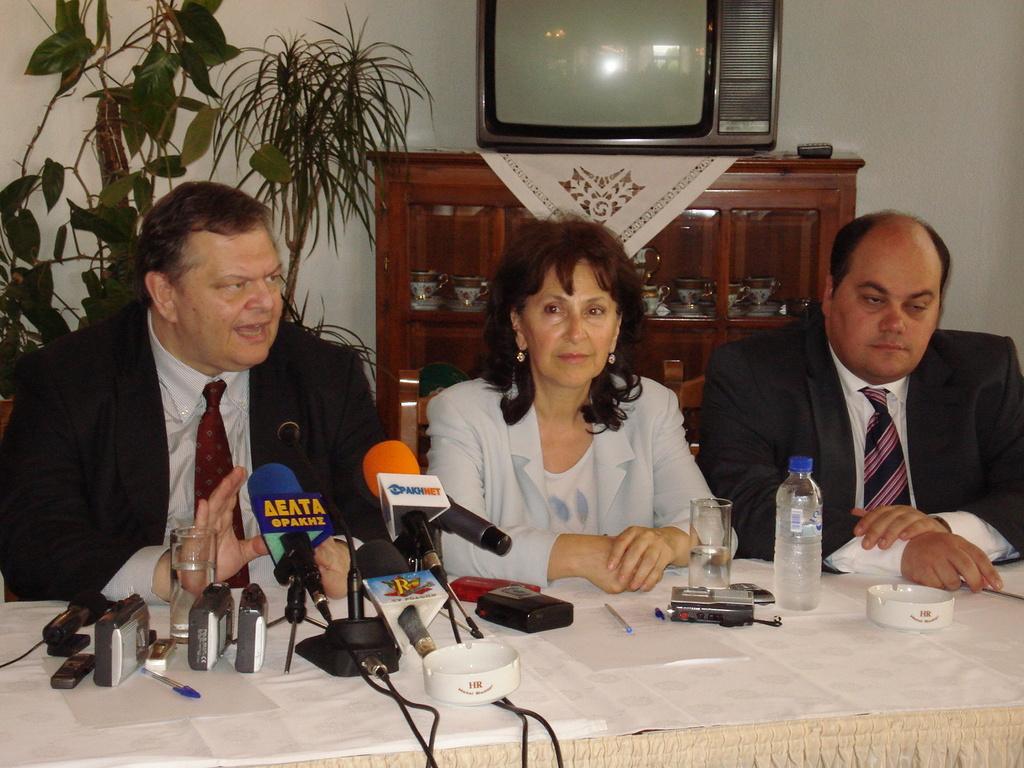In one or two sentences, can you explain what this image depicts? In this picture there are two men and a woman those who are sitting in the center of the image, there is a table in front of them, on which there are glasses, mics and a bottle, there is a television at the top side of the image, on a desk and there is a plant in the background area of the image. 